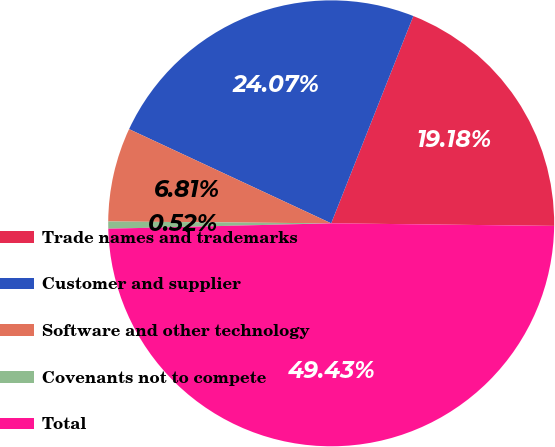Convert chart. <chart><loc_0><loc_0><loc_500><loc_500><pie_chart><fcel>Trade names and trademarks<fcel>Customer and supplier<fcel>Software and other technology<fcel>Covenants not to compete<fcel>Total<nl><fcel>19.18%<fcel>24.07%<fcel>6.81%<fcel>0.52%<fcel>49.44%<nl></chart> 